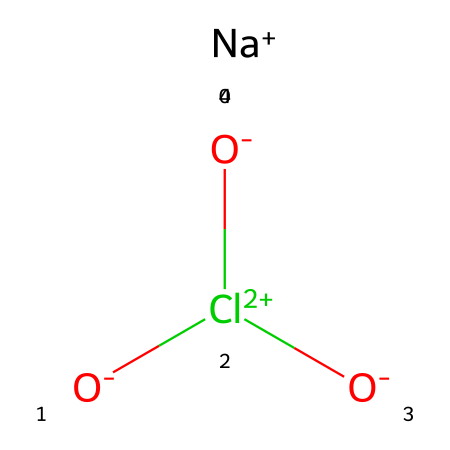What is the chemical name of the compound represented? The SMILES representation corresponds to sodium chlorate, where "Na" represents sodium and "Cl(=O)=O" indicates the chlorate ion.
Answer: sodium chlorate How many oxygen atoms are present in this chemical? The chemical structure shows two oxygen atoms in the chlorate ion (Cl(=O)=O) plus one connected to sodium, resulting in three total oxygen atoms.
Answer: three What type of reaction can sodium chlorate participate in as an oxidizer? Sodium chlorate can participate in redox reactions, where it acts as an oxidizing agent to oxidize other substances while being reduced itself.
Answer: redox reactions What ion is responsible for the oxidizing properties in sodium chlorate? The chlorate ion (ClO3-) contains chlorine in a higher oxidation state, which is responsible for the compound's oxidizing properties.
Answer: chlorate ion How many bonds are there between the chlorine and the oxygen atoms in this structure? There are three bonds: one double bond (C=O) and two single bonds (C-O) connecting chlorine to two oxygen atoms, resulting in a total of three bonds.
Answer: three What is the oxidation state of chlorine in sodium chlorate? In sodium chlorate, chlorine has an oxidation state of +5, as determined by its bonds with oxygen which typically have an oxidation state of -2.
Answer: +5 